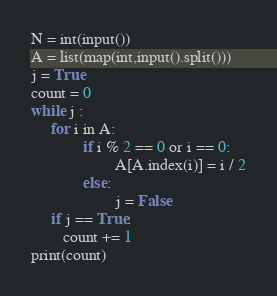Convert code to text. <code><loc_0><loc_0><loc_500><loc_500><_Python_>N = int(input())
A = list(map(int,input().split()))
j = True
count = 0
while j :
     for i in A:
             if i % 2 == 0 or i == 0:
                     A[A.index(i)] = i / 2
             else:
                     j = False
     if j == True:             
     	count += 1
print(count)</code> 